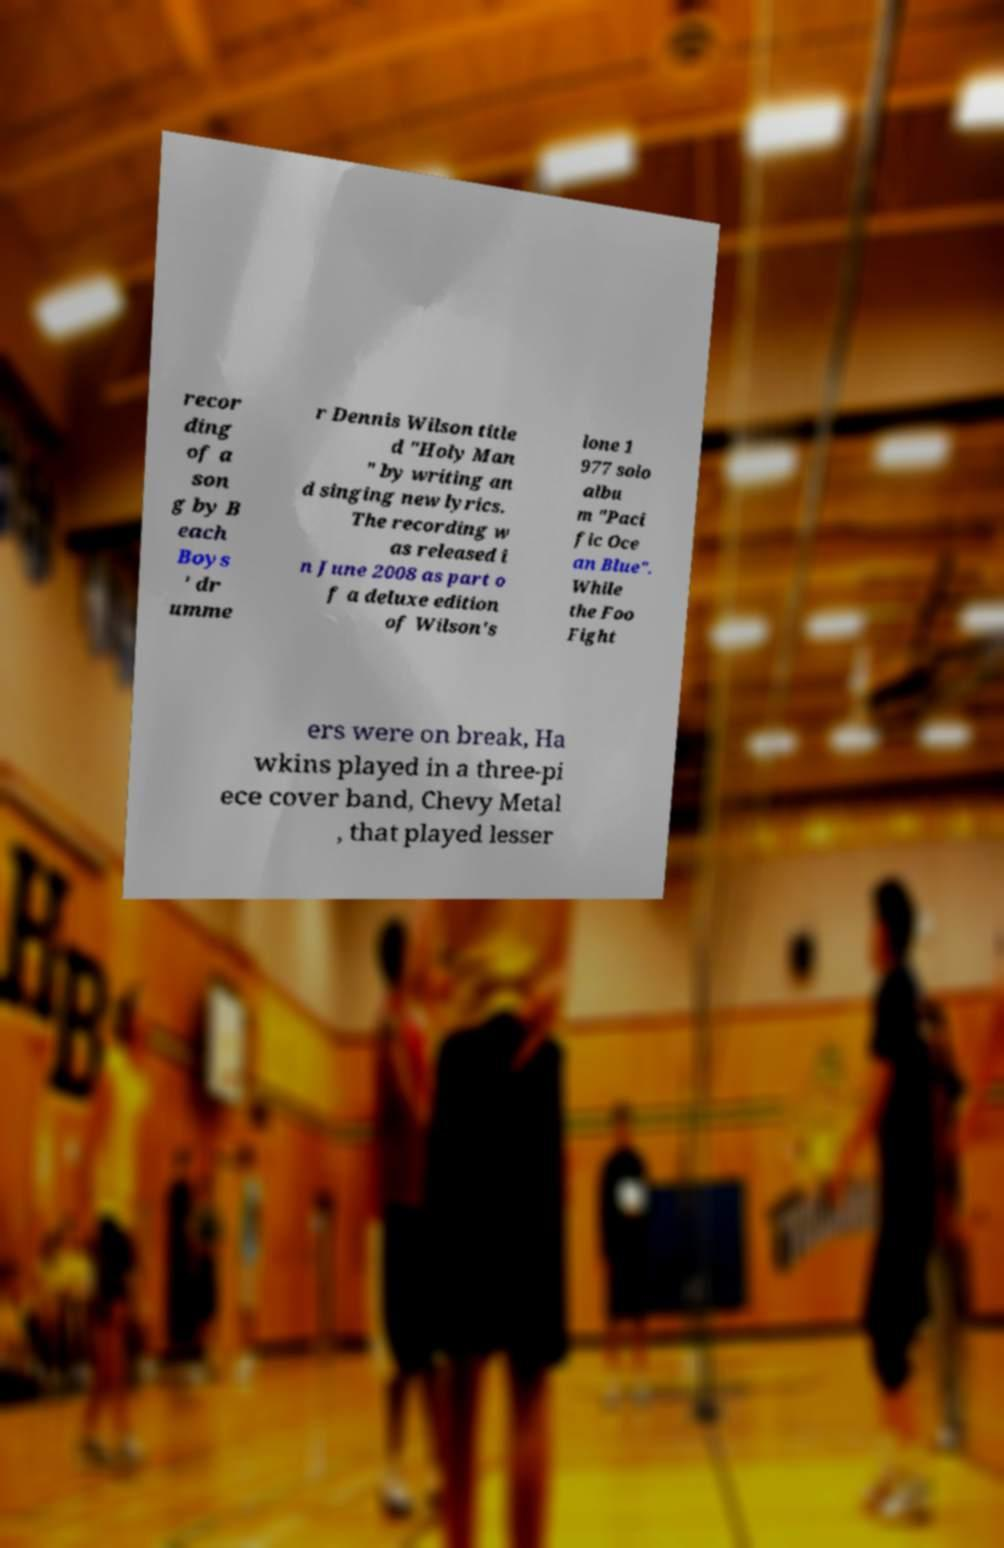I need the written content from this picture converted into text. Can you do that? recor ding of a son g by B each Boys ' dr umme r Dennis Wilson title d "Holy Man " by writing an d singing new lyrics. The recording w as released i n June 2008 as part o f a deluxe edition of Wilson's lone 1 977 solo albu m "Paci fic Oce an Blue". While the Foo Fight ers were on break, Ha wkins played in a three-pi ece cover band, Chevy Metal , that played lesser 